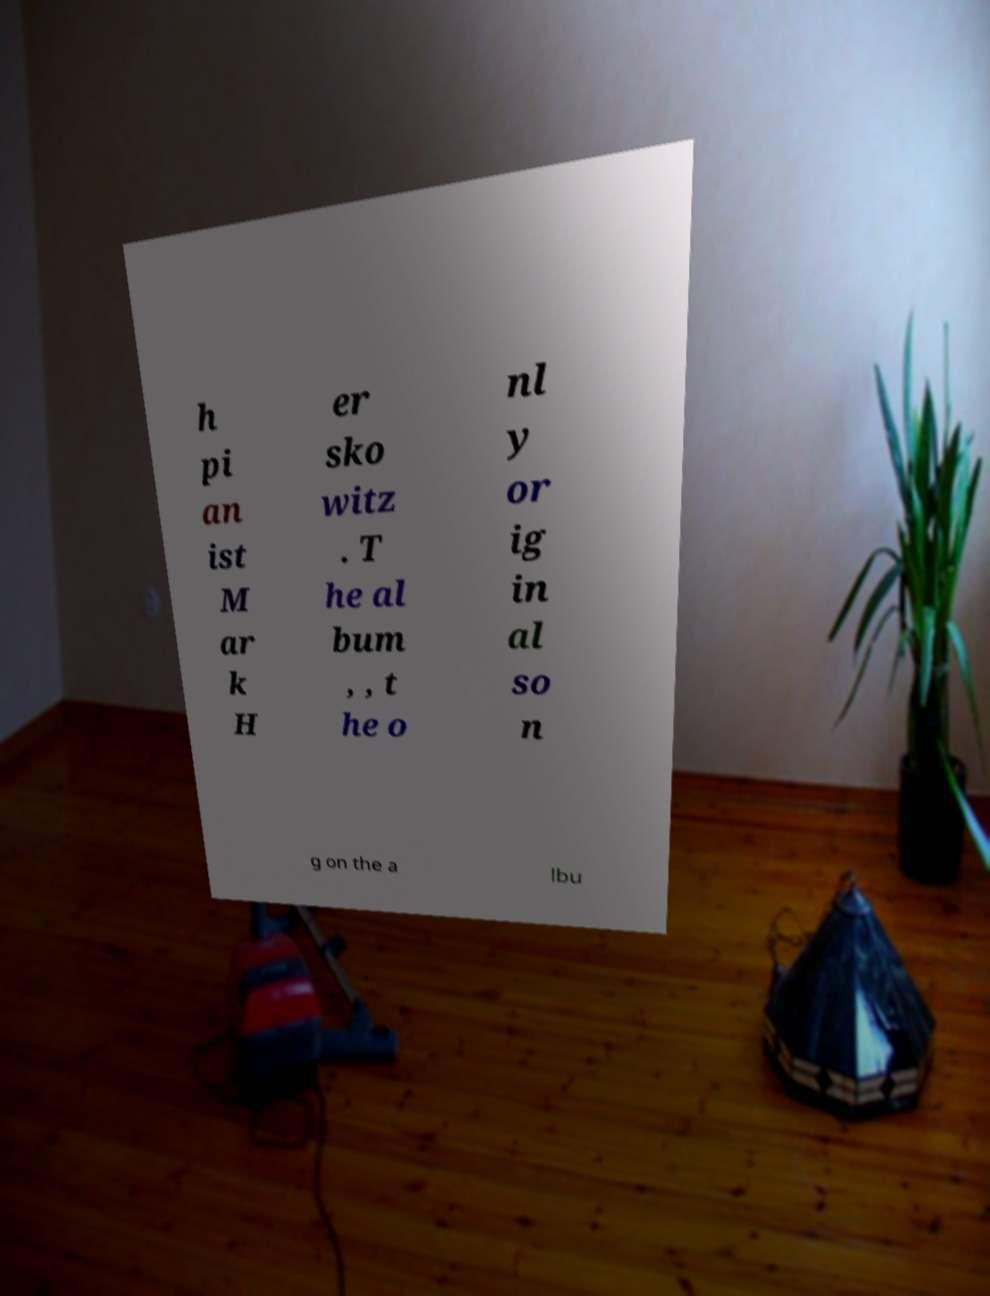I need the written content from this picture converted into text. Can you do that? h pi an ist M ar k H er sko witz . T he al bum , , t he o nl y or ig in al so n g on the a lbu 